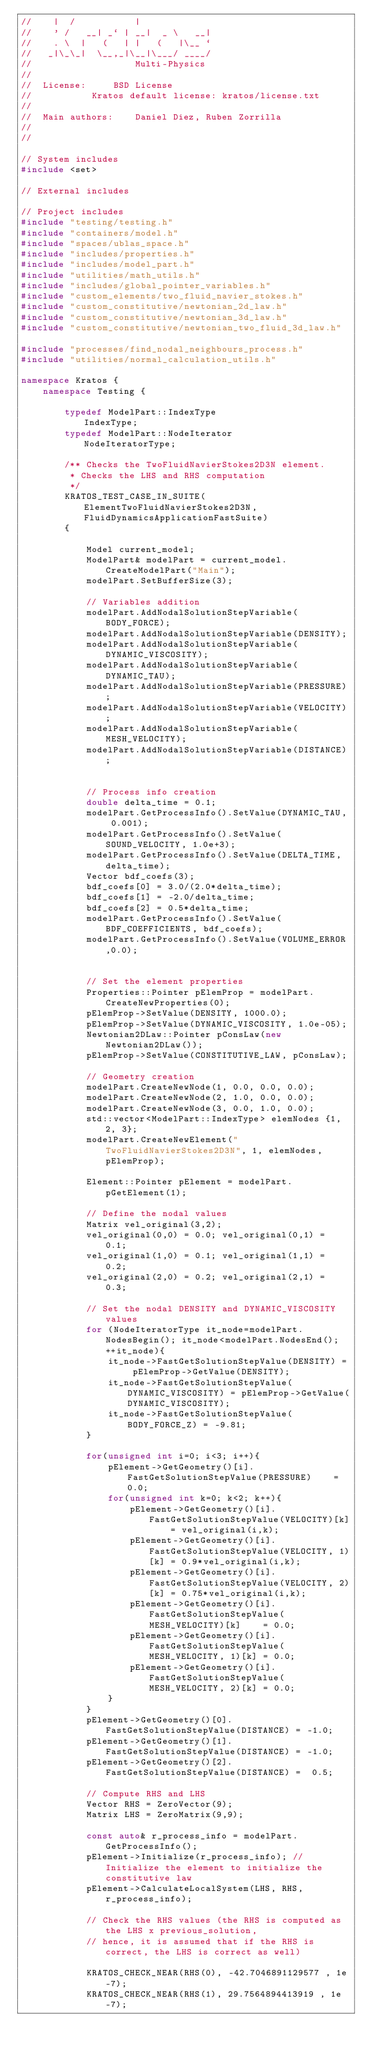Convert code to text. <code><loc_0><loc_0><loc_500><loc_500><_C++_>//    |  /           |
//    ' /   __| _` | __|  _ \   __|
//    . \  |   (   | |   (   |\__ `
//   _|\_\_|  \__,_|\__|\___/ ____/
//                   Multi-Physics
//
//  License:		 BSD License
//					 Kratos default license: kratos/license.txt
//
//  Main authors:    Daniel Diez, Ruben Zorrilla
//
//

// System includes
#include <set>

// External includes

// Project includes
#include "testing/testing.h"
#include "containers/model.h"
#include "spaces/ublas_space.h"
#include "includes/properties.h"
#include "includes/model_part.h"
#include "utilities/math_utils.h"
#include "includes/global_pointer_variables.h"
#include "custom_elements/two_fluid_navier_stokes.h"
#include "custom_constitutive/newtonian_2d_law.h"
#include "custom_constitutive/newtonian_3d_law.h"
#include "custom_constitutive/newtonian_two_fluid_3d_law.h"

#include "processes/find_nodal_neighbours_process.h"
#include "utilities/normal_calculation_utils.h"

namespace Kratos {
    namespace Testing {

        typedef ModelPart::IndexType									 IndexType;
        typedef ModelPart::NodeIterator					          NodeIteratorType;

        /** Checks the TwoFluidNavierStokes2D3N element.
         * Checks the LHS and RHS computation
         */
        KRATOS_TEST_CASE_IN_SUITE(ElementTwoFluidNavierStokes2D3N, FluidDynamicsApplicationFastSuite)
        {

            Model current_model;
            ModelPart& modelPart = current_model.CreateModelPart("Main");
            modelPart.SetBufferSize(3);

            // Variables addition
            modelPart.AddNodalSolutionStepVariable(BODY_FORCE);
            modelPart.AddNodalSolutionStepVariable(DENSITY);
            modelPart.AddNodalSolutionStepVariable(DYNAMIC_VISCOSITY);
            modelPart.AddNodalSolutionStepVariable(DYNAMIC_TAU);
            modelPart.AddNodalSolutionStepVariable(PRESSURE);
            modelPart.AddNodalSolutionStepVariable(VELOCITY);
            modelPart.AddNodalSolutionStepVariable(MESH_VELOCITY);
            modelPart.AddNodalSolutionStepVariable(DISTANCE);
            

            // Process info creation
            double delta_time = 0.1;
            modelPart.GetProcessInfo().SetValue(DYNAMIC_TAU, 0.001);
            modelPart.GetProcessInfo().SetValue(SOUND_VELOCITY, 1.0e+3);
            modelPart.GetProcessInfo().SetValue(DELTA_TIME, delta_time);
            Vector bdf_coefs(3);
            bdf_coefs[0] = 3.0/(2.0*delta_time);
            bdf_coefs[1] = -2.0/delta_time;
            bdf_coefs[2] = 0.5*delta_time;
            modelPart.GetProcessInfo().SetValue(BDF_COEFFICIENTS, bdf_coefs);
            modelPart.GetProcessInfo().SetValue(VOLUME_ERROR,0.0);


            // Set the element properties
            Properties::Pointer pElemProp = modelPart.CreateNewProperties(0);
            pElemProp->SetValue(DENSITY, 1000.0);
            pElemProp->SetValue(DYNAMIC_VISCOSITY, 1.0e-05);
            Newtonian2DLaw::Pointer pConsLaw(new Newtonian2DLaw());
            pElemProp->SetValue(CONSTITUTIVE_LAW, pConsLaw);

            // Geometry creation
            modelPart.CreateNewNode(1, 0.0, 0.0, 0.0);
            modelPart.CreateNewNode(2, 1.0, 0.0, 0.0);
            modelPart.CreateNewNode(3, 0.0, 1.0, 0.0);
            std::vector<ModelPart::IndexType> elemNodes {1, 2, 3};
            modelPart.CreateNewElement("TwoFluidNavierStokes2D3N", 1, elemNodes, pElemProp);

            Element::Pointer pElement = modelPart.pGetElement(1);

            // Define the nodal values
            Matrix vel_original(3,2);
            vel_original(0,0) = 0.0; vel_original(0,1) = 0.1;
            vel_original(1,0) = 0.1; vel_original(1,1) = 0.2;
            vel_original(2,0) = 0.2; vel_original(2,1) = 0.3;

            // Set the nodal DENSITY and DYNAMIC_VISCOSITY values
            for (NodeIteratorType it_node=modelPart.NodesBegin(); it_node<modelPart.NodesEnd(); ++it_node){
                it_node->FastGetSolutionStepValue(DENSITY) = pElemProp->GetValue(DENSITY);
                it_node->FastGetSolutionStepValue(DYNAMIC_VISCOSITY) = pElemProp->GetValue(DYNAMIC_VISCOSITY);
                it_node->FastGetSolutionStepValue(BODY_FORCE_Z) = -9.81;
            }

            for(unsigned int i=0; i<3; i++){
                pElement->GetGeometry()[i].FastGetSolutionStepValue(PRESSURE)    = 0.0;
                for(unsigned int k=0; k<2; k++){
                    pElement->GetGeometry()[i].FastGetSolutionStepValue(VELOCITY)[k]    = vel_original(i,k);
                    pElement->GetGeometry()[i].FastGetSolutionStepValue(VELOCITY, 1)[k] = 0.9*vel_original(i,k);
                    pElement->GetGeometry()[i].FastGetSolutionStepValue(VELOCITY, 2)[k] = 0.75*vel_original(i,k);
                    pElement->GetGeometry()[i].FastGetSolutionStepValue(MESH_VELOCITY)[k]    = 0.0;
                    pElement->GetGeometry()[i].FastGetSolutionStepValue(MESH_VELOCITY, 1)[k] = 0.0;
                    pElement->GetGeometry()[i].FastGetSolutionStepValue(MESH_VELOCITY, 2)[k] = 0.0;
                }
            }
            pElement->GetGeometry()[0].FastGetSolutionStepValue(DISTANCE) = -1.0;
            pElement->GetGeometry()[1].FastGetSolutionStepValue(DISTANCE) = -1.0;
            pElement->GetGeometry()[2].FastGetSolutionStepValue(DISTANCE) =  0.5;

            // Compute RHS and LHS
            Vector RHS = ZeroVector(9);
            Matrix LHS = ZeroMatrix(9,9);

            const auto& r_process_info = modelPart.GetProcessInfo();
            pElement->Initialize(r_process_info); // Initialize the element to initialize the constitutive law
            pElement->CalculateLocalSystem(LHS, RHS, r_process_info);

            // Check the RHS values (the RHS is computed as the LHS x previous_solution,
            // hence, it is assumed that if the RHS is correct, the LHS is correct as well)

            KRATOS_CHECK_NEAR(RHS(0), -42.7046891129577 , 1e-7);
            KRATOS_CHECK_NEAR(RHS(1), 29.7564894413919 , 1e-7);</code> 